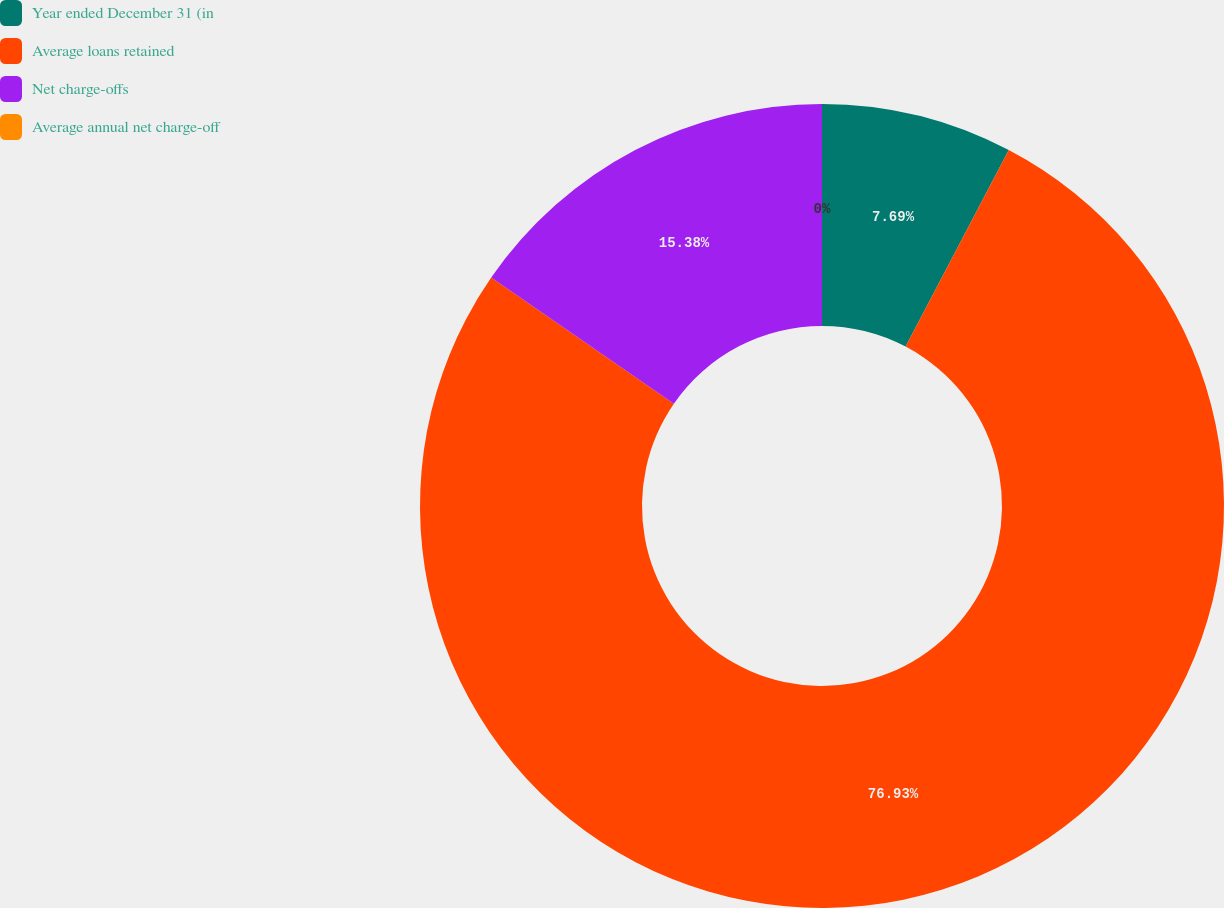Convert chart to OTSL. <chart><loc_0><loc_0><loc_500><loc_500><pie_chart><fcel>Year ended December 31 (in<fcel>Average loans retained<fcel>Net charge-offs<fcel>Average annual net charge-off<nl><fcel>7.69%<fcel>76.92%<fcel>15.38%<fcel>0.0%<nl></chart> 